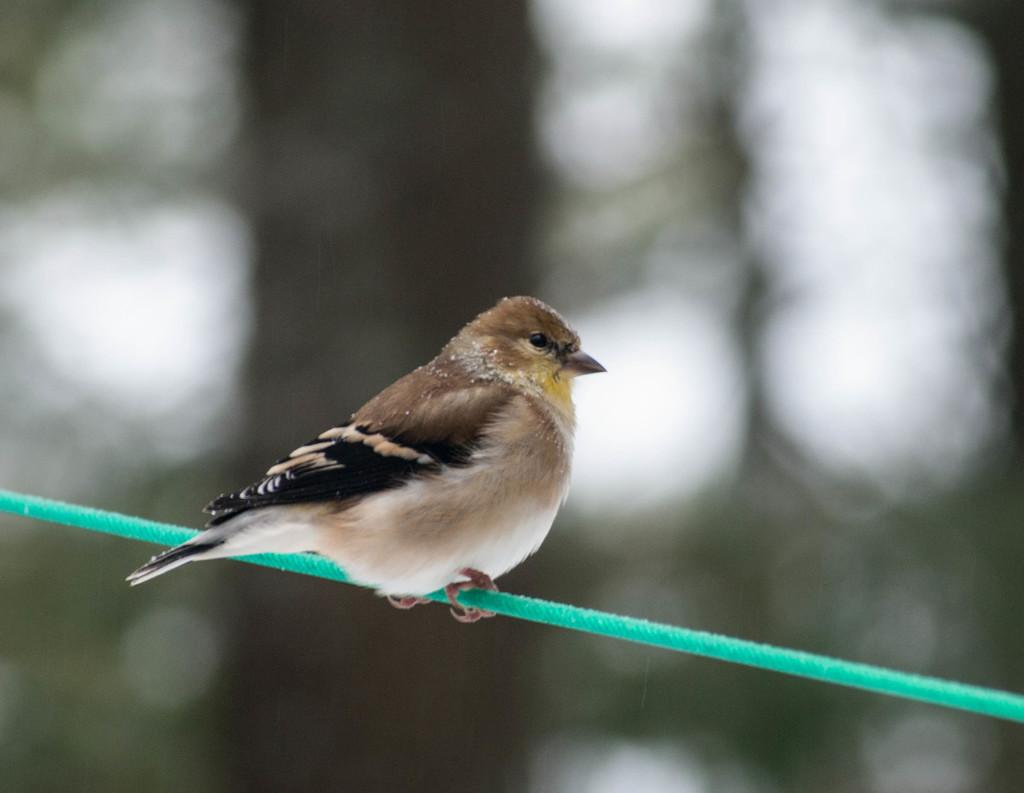What type of animal is present in the image? There is a bird in the image. What is the bird doing in the image? The bird is sitting on a rope. How does the bird attack the rope in the image? The bird does not attack the rope in the image; it is simply sitting on it. What type of paste is being used by the bird to stick itself to the rope in the image? There is no paste present in the image, and the bird is not sticking itself to the rope. 